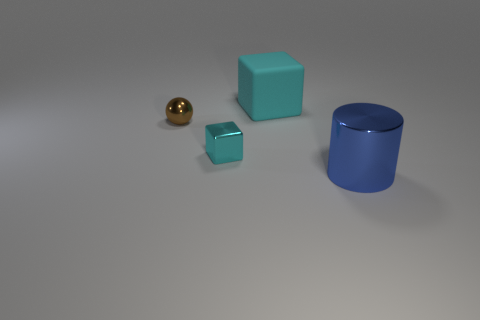Add 2 cylinders. How many objects exist? 6 Subtract 1 balls. How many balls are left? 0 Subtract all purple cylinders. Subtract all gray cubes. How many cylinders are left? 1 Subtract all cyan metallic cubes. Subtract all big cylinders. How many objects are left? 2 Add 3 brown objects. How many brown objects are left? 4 Add 1 blue metal blocks. How many blue metal blocks exist? 1 Subtract 0 gray cylinders. How many objects are left? 4 Subtract all cylinders. How many objects are left? 3 